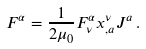<formula> <loc_0><loc_0><loc_500><loc_500>F ^ { \alpha } = \frac { 1 } { 2 \mu _ { 0 } } F ^ { \alpha } _ { \nu } x ^ { \nu } _ { , a } J ^ { a } \, .</formula> 